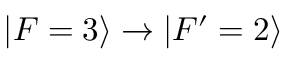<formula> <loc_0><loc_0><loc_500><loc_500>| F = 3 \rangle \rightarrow | F ^ { \prime } = 2 \rangle</formula> 